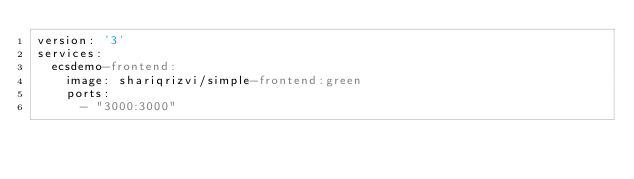Convert code to text. <code><loc_0><loc_0><loc_500><loc_500><_YAML_>version: '3'
services:
  ecsdemo-frontend:
    image: shariqrizvi/simple-frontend:green
    ports:
      - "3000:3000"</code> 